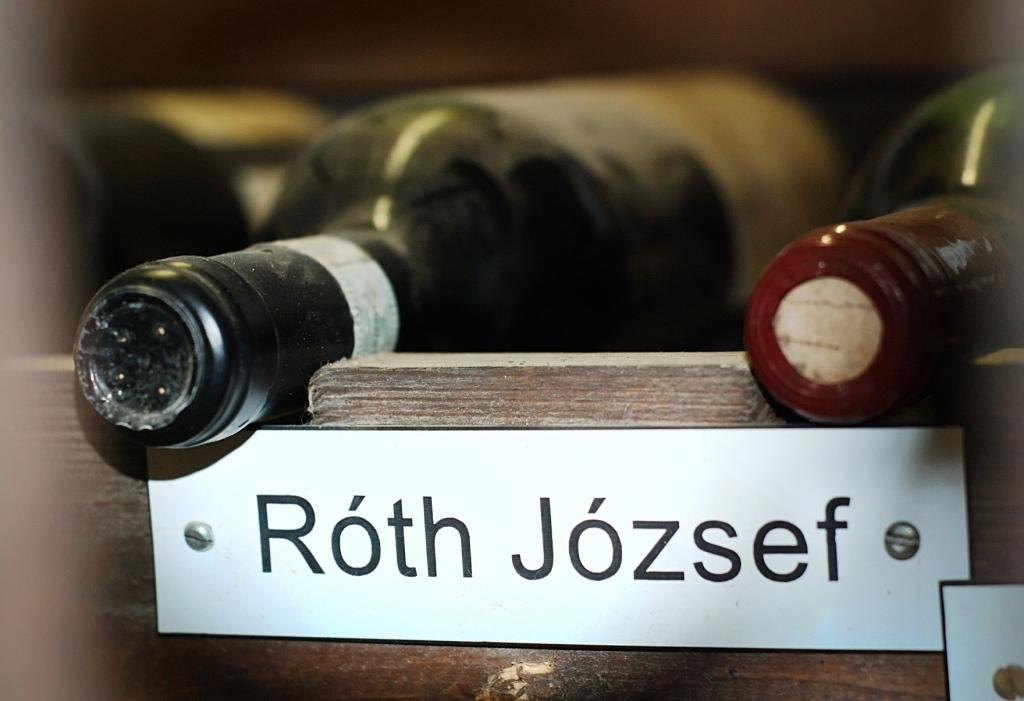<image>
Write a terse but informative summary of the picture. A sholf with wine bottles laying horizontally and the name Roth Jozsef  labeled on the shelf. 